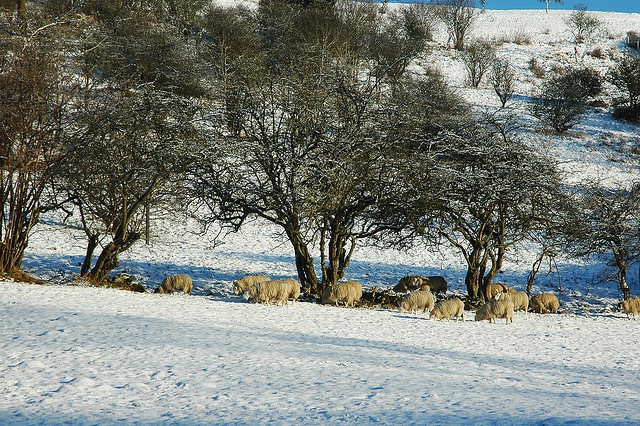Describe the objects in this image and their specific colors. I can see sheep in black, tan, and olive tones, sheep in black, olive, tan, and gray tones, sheep in black, tan, and olive tones, sheep in black, gray, and darkgray tones, and sheep in black, tan, olive, and gray tones in this image. 